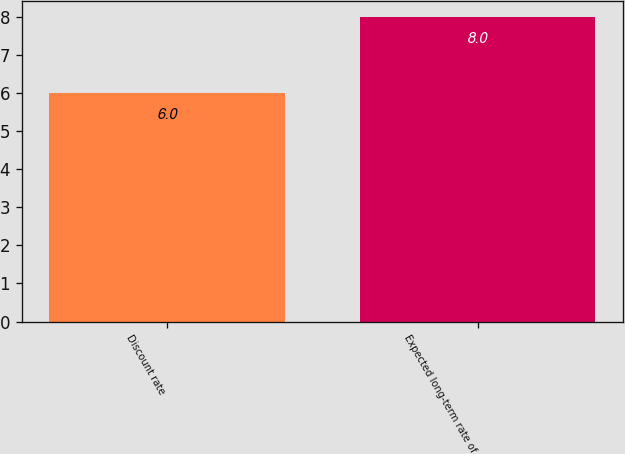<chart> <loc_0><loc_0><loc_500><loc_500><bar_chart><fcel>Discount rate<fcel>Expected long-term rate of<nl><fcel>6<fcel>8<nl></chart> 